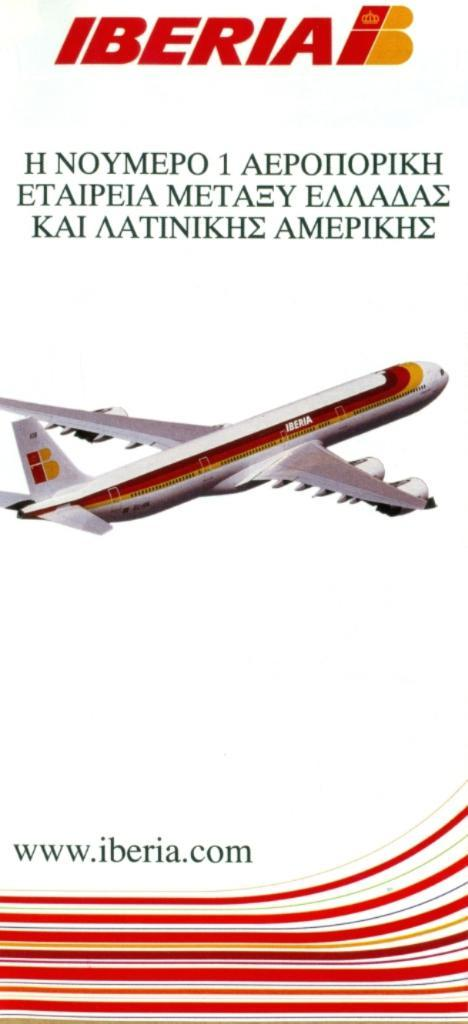<image>
Create a compact narrative representing the image presented. An ad for Iberia airlines including their website address. 